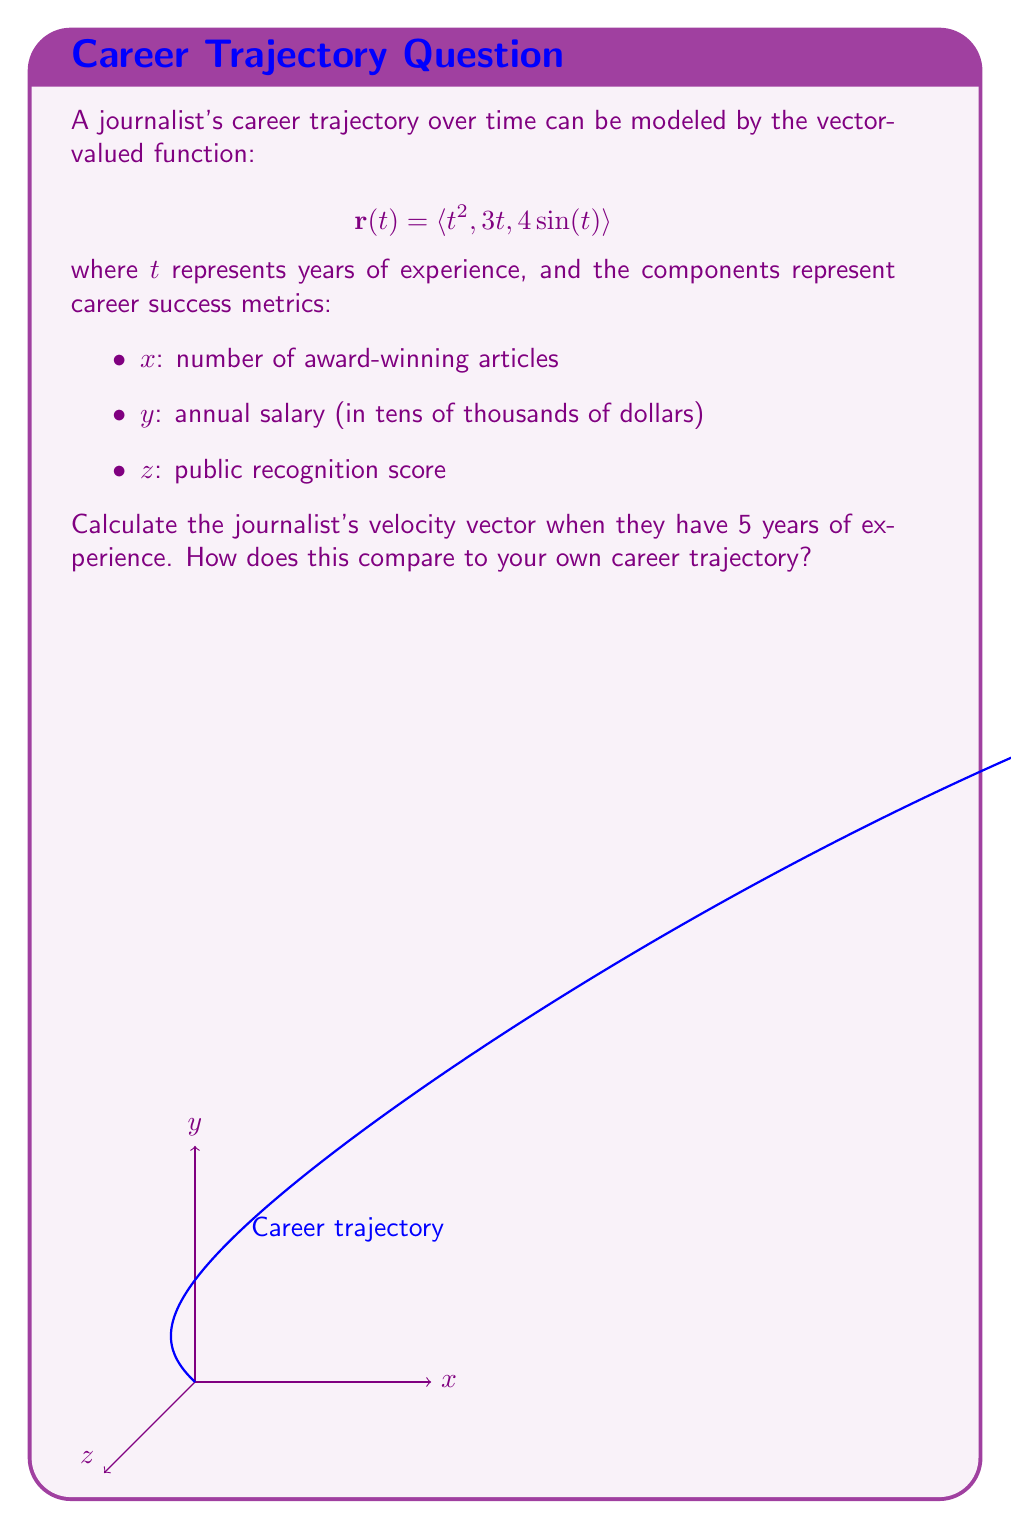Solve this math problem. To find the velocity vector at $t=5$, we need to differentiate the position vector $\mathbf{r}(t)$ with respect to $t$:

1) First, let's find $\mathbf{r}'(t)$:
   $$\mathbf{r}'(t) = \langle \frac{d}{dt}(t^2), \frac{d}{dt}(3t), \frac{d}{dt}(4\sin(t)) \rangle$$

2) Differentiating each component:
   $$\mathbf{r}'(t) = \langle 2t, 3, 4\cos(t) \rangle$$

3) This is the velocity vector function. To find the velocity at $t=5$, we substitute $t=5$:
   $$\mathbf{r}'(5) = \langle 2(5), 3, 4\cos(5) \rangle$$

4) Simplifying:
   $$\mathbf{r}'(5) = \langle 10, 3, 4\cos(5) \rangle$$

5) Using a calculator for $\cos(5)$ (in radians):
   $$\mathbf{r}'(5) \approx \langle 10, 3, 1.15 \rangle$$

This velocity vector indicates that at 5 years of experience:
- The rate of producing award-winning articles is increasing by 10 per year
- The salary is increasing by $30,000 per year
- The public recognition score is increasing by approximately 1.15 points per year
Answer: $\mathbf{r}'(5) \approx \langle 10, 3, 1.15 \rangle$ 